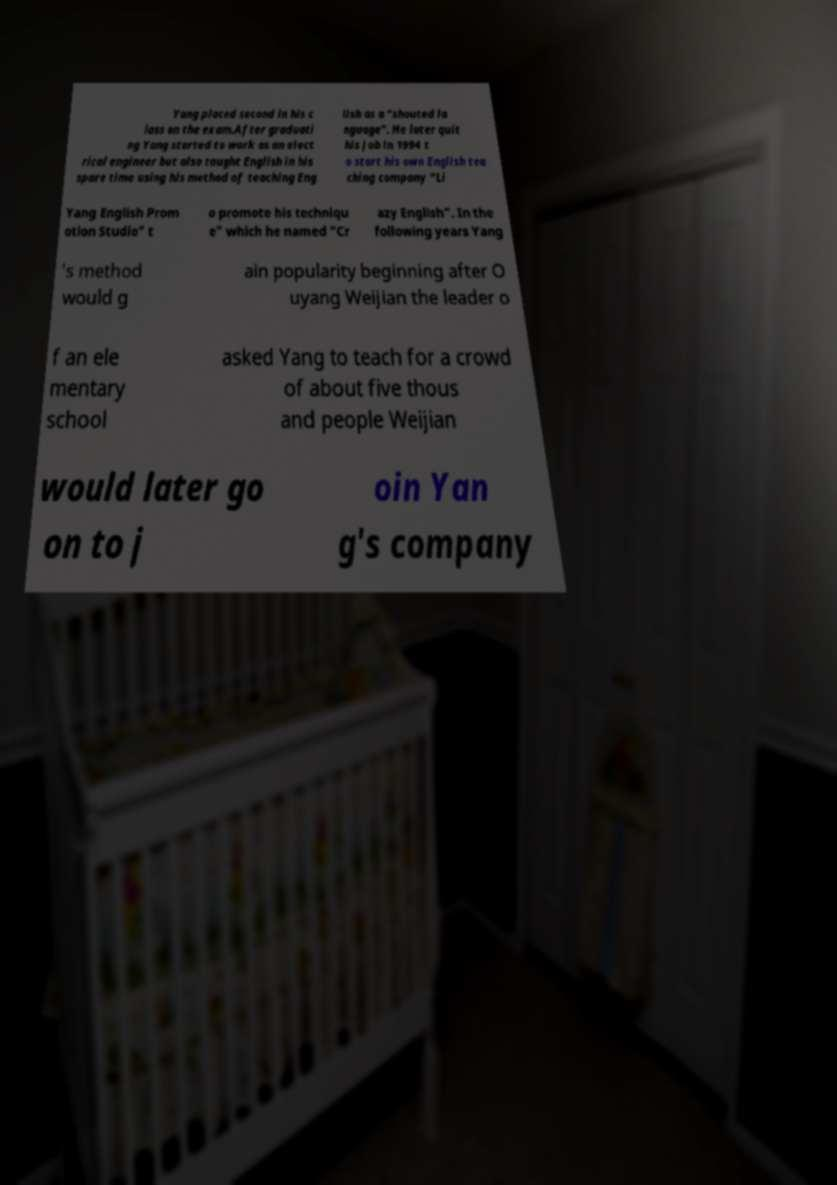Can you read and provide the text displayed in the image?This photo seems to have some interesting text. Can you extract and type it out for me? Yang placed second in his c lass on the exam.After graduati ng Yang started to work as an elect rical engineer but also taught English in his spare time using his method of teaching Eng lish as a “shouted la nguage”. He later quit his job in 1994 t o start his own English tea ching company “Li Yang English Prom otion Studio" t o promote his techniqu e" which he named “Cr azy English”. In the following years Yang 's method would g ain popularity beginning after O uyang Weijian the leader o f an ele mentary school asked Yang to teach for a crowd of about five thous and people Weijian would later go on to j oin Yan g's company 